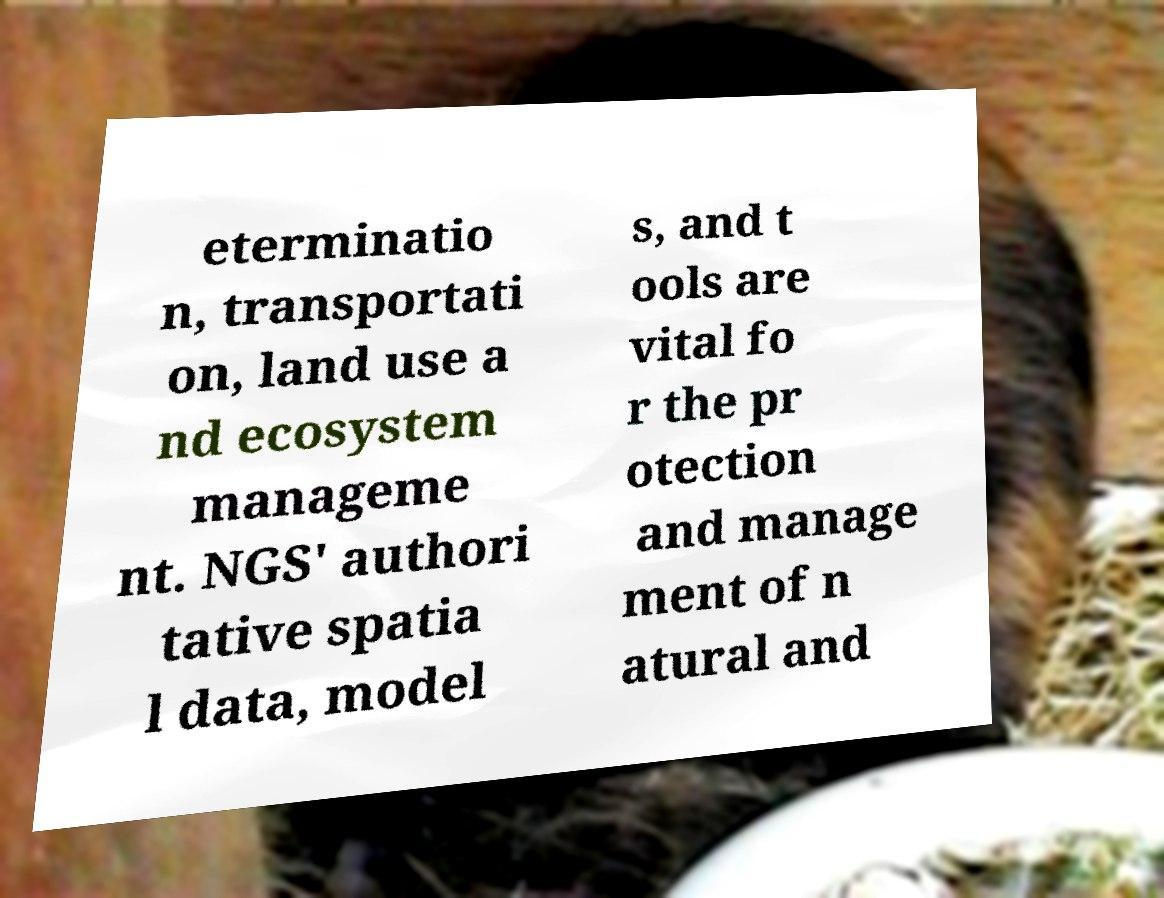Can you read and provide the text displayed in the image?This photo seems to have some interesting text. Can you extract and type it out for me? eterminatio n, transportati on, land use a nd ecosystem manageme nt. NGS' authori tative spatia l data, model s, and t ools are vital fo r the pr otection and manage ment of n atural and 